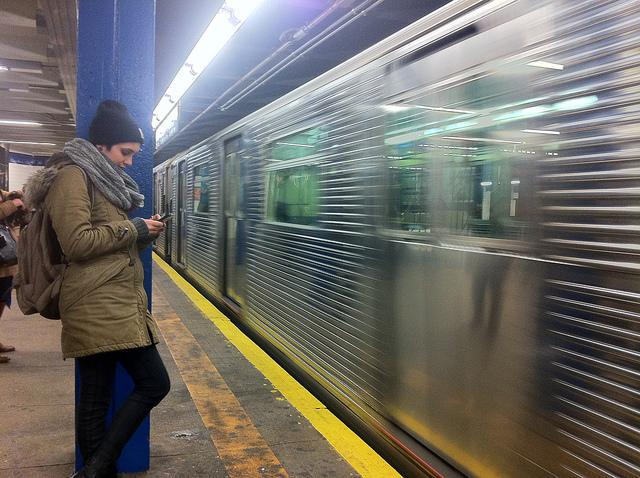The person next to the train looks like who?

Choices:
A) tracy ifeachor
B) james horner
C) ned beatty
D) margaret qualley margaret qualley 